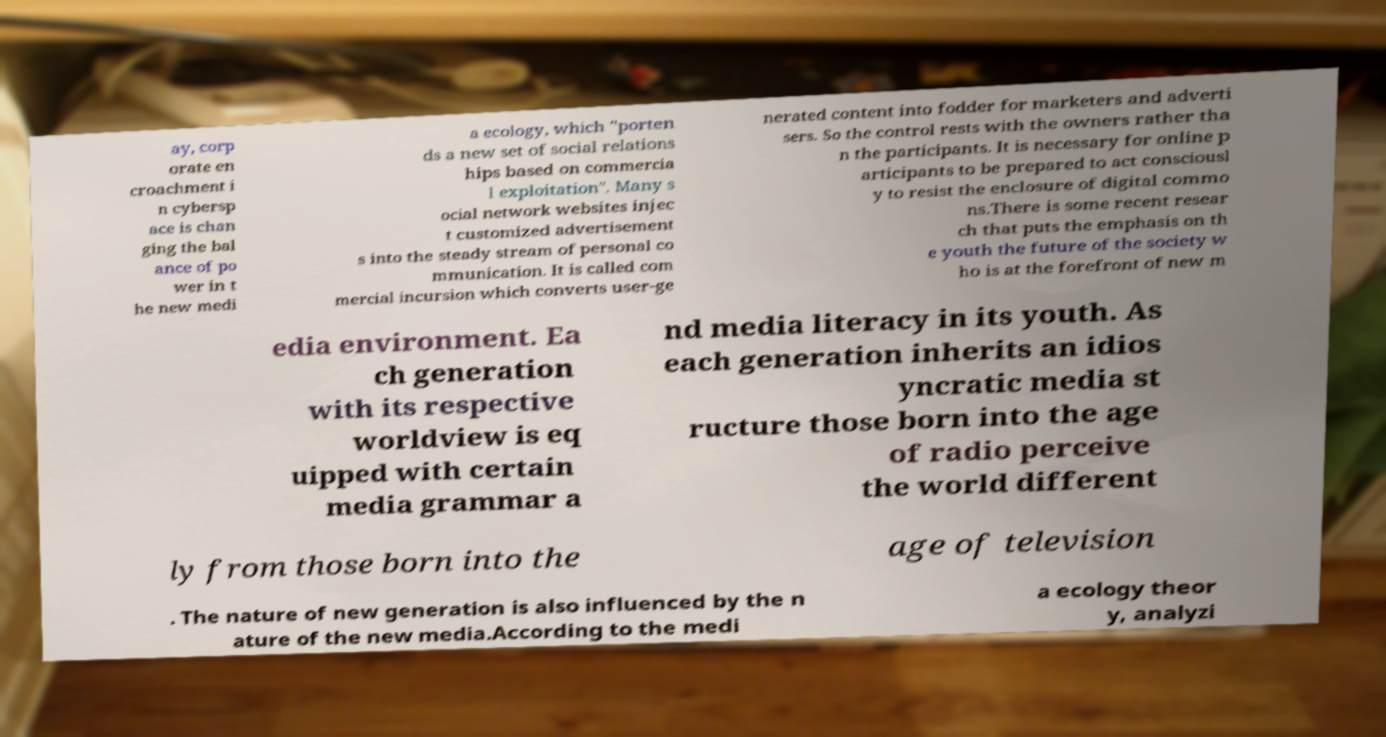Please read and relay the text visible in this image. What does it say? ay, corp orate en croachment i n cybersp ace is chan ging the bal ance of po wer in t he new medi a ecology, which "porten ds a new set of social relations hips based on commercia l exploitation". Many s ocial network websites injec t customized advertisement s into the steady stream of personal co mmunication. It is called com mercial incursion which converts user-ge nerated content into fodder for marketers and adverti sers. So the control rests with the owners rather tha n the participants. It is necessary for online p articipants to be prepared to act consciousl y to resist the enclosure of digital commo ns.There is some recent resear ch that puts the emphasis on th e youth the future of the society w ho is at the forefront of new m edia environment. Ea ch generation with its respective worldview is eq uipped with certain media grammar a nd media literacy in its youth. As each generation inherits an idios yncratic media st ructure those born into the age of radio perceive the world different ly from those born into the age of television . The nature of new generation is also influenced by the n ature of the new media.According to the medi a ecology theor y, analyzi 